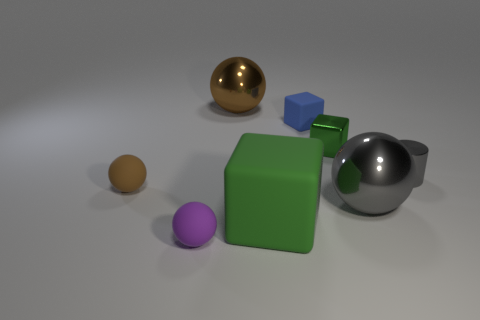Add 1 large brown metal things. How many objects exist? 9 Subtract all cylinders. How many objects are left? 7 Subtract 0 yellow spheres. How many objects are left? 8 Subtract all big green rubber cubes. Subtract all metal blocks. How many objects are left? 6 Add 3 tiny brown matte objects. How many tiny brown matte objects are left? 4 Add 1 big green cubes. How many big green cubes exist? 2 